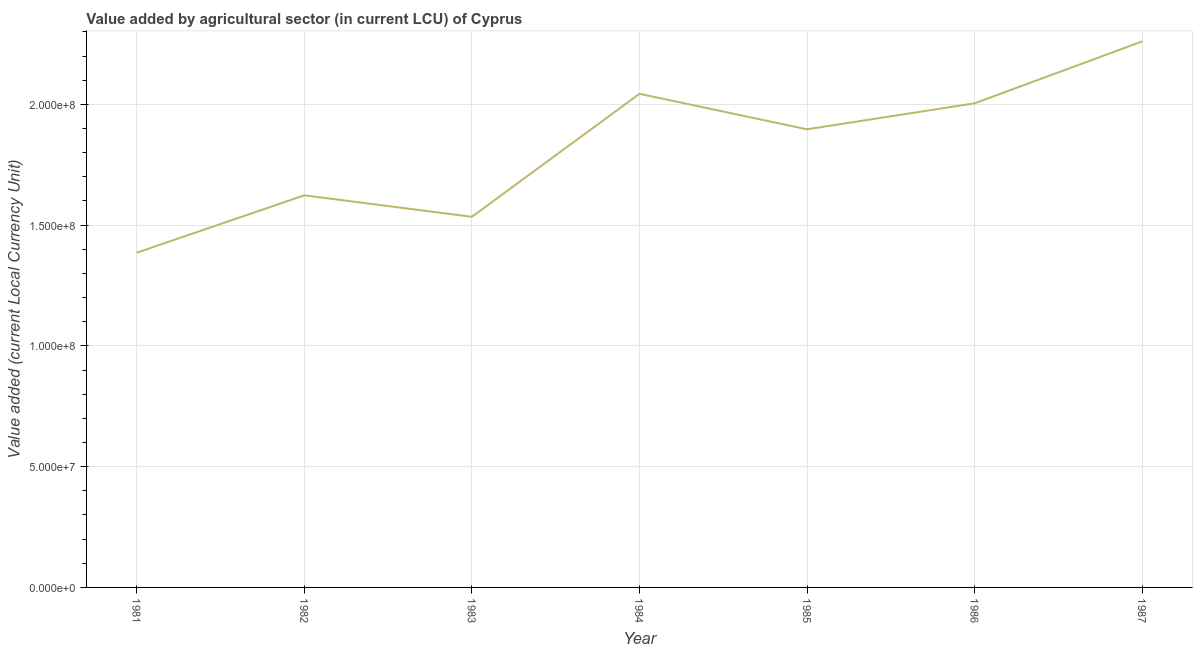What is the value added by agriculture sector in 1983?
Make the answer very short. 1.53e+08. Across all years, what is the maximum value added by agriculture sector?
Your response must be concise. 2.26e+08. Across all years, what is the minimum value added by agriculture sector?
Your answer should be very brief. 1.39e+08. In which year was the value added by agriculture sector minimum?
Ensure brevity in your answer.  1981. What is the sum of the value added by agriculture sector?
Offer a terse response. 1.27e+09. What is the difference between the value added by agriculture sector in 1982 and 1984?
Give a very brief answer. -4.20e+07. What is the average value added by agriculture sector per year?
Make the answer very short. 1.82e+08. What is the median value added by agriculture sector?
Your answer should be compact. 1.90e+08. Do a majority of the years between 1982 and 1986 (inclusive) have value added by agriculture sector greater than 150000000 LCU?
Offer a terse response. Yes. What is the ratio of the value added by agriculture sector in 1983 to that in 1987?
Provide a short and direct response. 0.68. Is the value added by agriculture sector in 1981 less than that in 1987?
Make the answer very short. Yes. What is the difference between the highest and the second highest value added by agriculture sector?
Your answer should be very brief. 2.17e+07. Is the sum of the value added by agriculture sector in 1983 and 1984 greater than the maximum value added by agriculture sector across all years?
Provide a short and direct response. Yes. What is the difference between the highest and the lowest value added by agriculture sector?
Offer a terse response. 8.75e+07. How many lines are there?
Ensure brevity in your answer.  1. Does the graph contain any zero values?
Your answer should be very brief. No. What is the title of the graph?
Your response must be concise. Value added by agricultural sector (in current LCU) of Cyprus. What is the label or title of the X-axis?
Your answer should be very brief. Year. What is the label or title of the Y-axis?
Offer a terse response. Value added (current Local Currency Unit). What is the Value added (current Local Currency Unit) of 1981?
Provide a short and direct response. 1.39e+08. What is the Value added (current Local Currency Unit) of 1982?
Make the answer very short. 1.62e+08. What is the Value added (current Local Currency Unit) of 1983?
Offer a terse response. 1.53e+08. What is the Value added (current Local Currency Unit) in 1984?
Offer a terse response. 2.04e+08. What is the Value added (current Local Currency Unit) in 1985?
Provide a succinct answer. 1.90e+08. What is the Value added (current Local Currency Unit) in 1986?
Give a very brief answer. 2.00e+08. What is the Value added (current Local Currency Unit) of 1987?
Ensure brevity in your answer.  2.26e+08. What is the difference between the Value added (current Local Currency Unit) in 1981 and 1982?
Provide a succinct answer. -2.37e+07. What is the difference between the Value added (current Local Currency Unit) in 1981 and 1983?
Provide a succinct answer. -1.49e+07. What is the difference between the Value added (current Local Currency Unit) in 1981 and 1984?
Offer a terse response. -6.58e+07. What is the difference between the Value added (current Local Currency Unit) in 1981 and 1985?
Your answer should be compact. -5.11e+07. What is the difference between the Value added (current Local Currency Unit) in 1981 and 1986?
Provide a succinct answer. -6.19e+07. What is the difference between the Value added (current Local Currency Unit) in 1981 and 1987?
Your response must be concise. -8.75e+07. What is the difference between the Value added (current Local Currency Unit) in 1982 and 1983?
Provide a short and direct response. 8.88e+06. What is the difference between the Value added (current Local Currency Unit) in 1982 and 1984?
Make the answer very short. -4.20e+07. What is the difference between the Value added (current Local Currency Unit) in 1982 and 1985?
Offer a terse response. -2.73e+07. What is the difference between the Value added (current Local Currency Unit) in 1982 and 1986?
Your answer should be very brief. -3.81e+07. What is the difference between the Value added (current Local Currency Unit) in 1982 and 1987?
Give a very brief answer. -6.37e+07. What is the difference between the Value added (current Local Currency Unit) in 1983 and 1984?
Provide a short and direct response. -5.09e+07. What is the difference between the Value added (current Local Currency Unit) in 1983 and 1985?
Provide a succinct answer. -3.62e+07. What is the difference between the Value added (current Local Currency Unit) in 1983 and 1986?
Provide a short and direct response. -4.70e+07. What is the difference between the Value added (current Local Currency Unit) in 1983 and 1987?
Provide a succinct answer. -7.26e+07. What is the difference between the Value added (current Local Currency Unit) in 1984 and 1985?
Your answer should be very brief. 1.47e+07. What is the difference between the Value added (current Local Currency Unit) in 1984 and 1986?
Ensure brevity in your answer.  3.93e+06. What is the difference between the Value added (current Local Currency Unit) in 1984 and 1987?
Provide a short and direct response. -2.17e+07. What is the difference between the Value added (current Local Currency Unit) in 1985 and 1986?
Give a very brief answer. -1.08e+07. What is the difference between the Value added (current Local Currency Unit) in 1985 and 1987?
Provide a succinct answer. -3.64e+07. What is the difference between the Value added (current Local Currency Unit) in 1986 and 1987?
Provide a succinct answer. -2.56e+07. What is the ratio of the Value added (current Local Currency Unit) in 1981 to that in 1982?
Keep it short and to the point. 0.85. What is the ratio of the Value added (current Local Currency Unit) in 1981 to that in 1983?
Your answer should be very brief. 0.9. What is the ratio of the Value added (current Local Currency Unit) in 1981 to that in 1984?
Make the answer very short. 0.68. What is the ratio of the Value added (current Local Currency Unit) in 1981 to that in 1985?
Offer a terse response. 0.73. What is the ratio of the Value added (current Local Currency Unit) in 1981 to that in 1986?
Keep it short and to the point. 0.69. What is the ratio of the Value added (current Local Currency Unit) in 1981 to that in 1987?
Your answer should be compact. 0.61. What is the ratio of the Value added (current Local Currency Unit) in 1982 to that in 1983?
Offer a terse response. 1.06. What is the ratio of the Value added (current Local Currency Unit) in 1982 to that in 1984?
Keep it short and to the point. 0.79. What is the ratio of the Value added (current Local Currency Unit) in 1982 to that in 1985?
Your answer should be compact. 0.86. What is the ratio of the Value added (current Local Currency Unit) in 1982 to that in 1986?
Your answer should be compact. 0.81. What is the ratio of the Value added (current Local Currency Unit) in 1982 to that in 1987?
Offer a terse response. 0.72. What is the ratio of the Value added (current Local Currency Unit) in 1983 to that in 1984?
Make the answer very short. 0.75. What is the ratio of the Value added (current Local Currency Unit) in 1983 to that in 1985?
Your answer should be compact. 0.81. What is the ratio of the Value added (current Local Currency Unit) in 1983 to that in 1986?
Give a very brief answer. 0.77. What is the ratio of the Value added (current Local Currency Unit) in 1983 to that in 1987?
Provide a short and direct response. 0.68. What is the ratio of the Value added (current Local Currency Unit) in 1984 to that in 1985?
Give a very brief answer. 1.08. What is the ratio of the Value added (current Local Currency Unit) in 1984 to that in 1986?
Your answer should be very brief. 1.02. What is the ratio of the Value added (current Local Currency Unit) in 1984 to that in 1987?
Provide a succinct answer. 0.9. What is the ratio of the Value added (current Local Currency Unit) in 1985 to that in 1986?
Provide a succinct answer. 0.95. What is the ratio of the Value added (current Local Currency Unit) in 1985 to that in 1987?
Your answer should be very brief. 0.84. What is the ratio of the Value added (current Local Currency Unit) in 1986 to that in 1987?
Give a very brief answer. 0.89. 